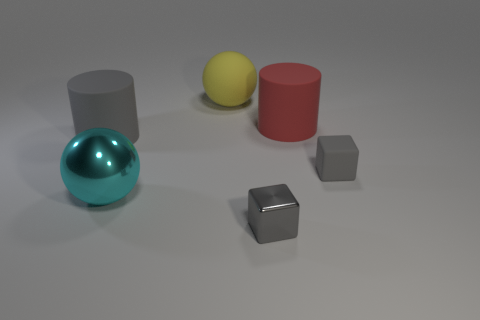Add 2 red cylinders. How many objects exist? 8 Subtract all spheres. How many objects are left? 4 Add 3 large cyan shiny things. How many large cyan shiny things exist? 4 Subtract 0 red balls. How many objects are left? 6 Subtract all gray metallic cubes. Subtract all small metal cubes. How many objects are left? 4 Add 6 big cylinders. How many big cylinders are left? 8 